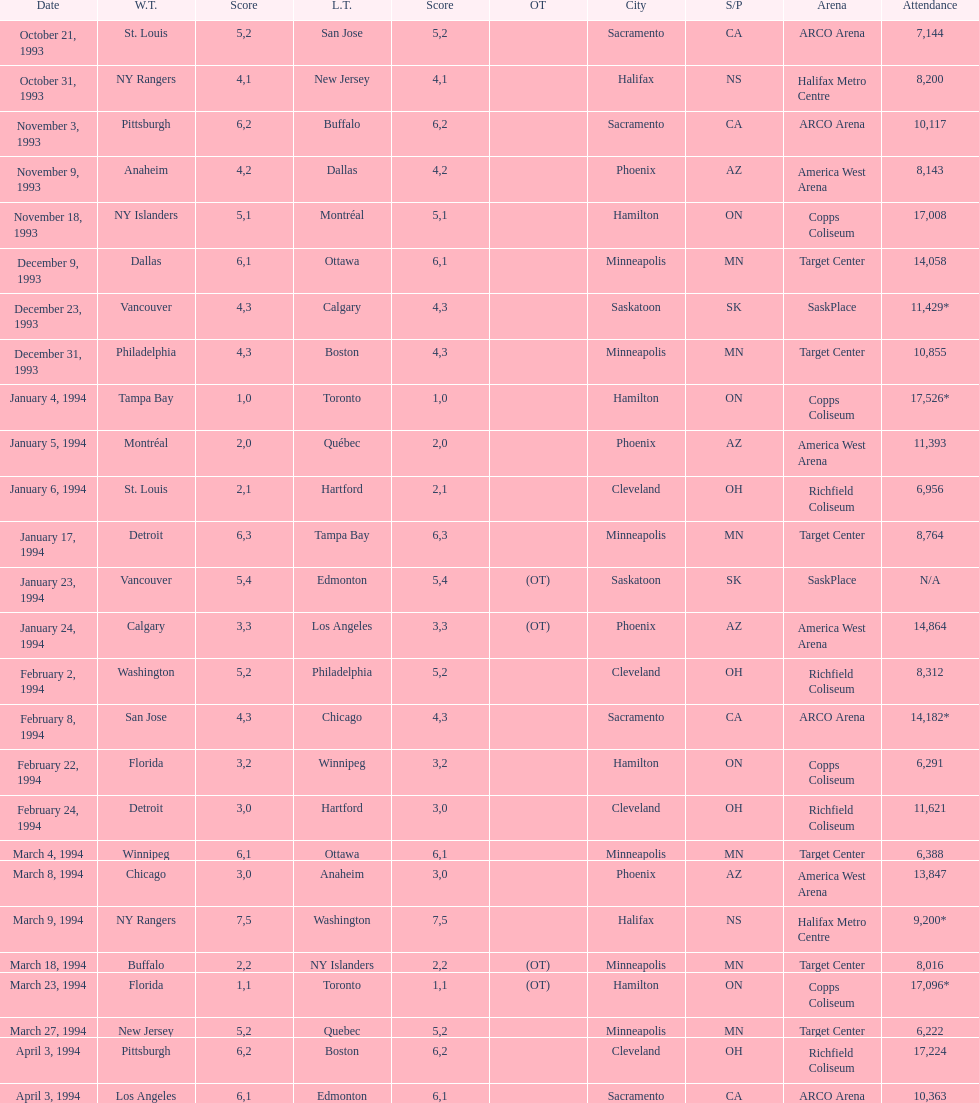I'm looking to parse the entire table for insights. Could you assist me with that? {'header': ['Date', 'W.T.', 'Score', 'L.T.', 'Score', 'OT', 'City', 'S/P', 'Arena', 'Attendance'], 'rows': [['October 21, 1993', 'St. Louis', '5', 'San Jose', '2', '', 'Sacramento', 'CA', 'ARCO Arena', '7,144'], ['October 31, 1993', 'NY Rangers', '4', 'New Jersey', '1', '', 'Halifax', 'NS', 'Halifax Metro Centre', '8,200'], ['November 3, 1993', 'Pittsburgh', '6', 'Buffalo', '2', '', 'Sacramento', 'CA', 'ARCO Arena', '10,117'], ['November 9, 1993', 'Anaheim', '4', 'Dallas', '2', '', 'Phoenix', 'AZ', 'America West Arena', '8,143'], ['November 18, 1993', 'NY Islanders', '5', 'Montréal', '1', '', 'Hamilton', 'ON', 'Copps Coliseum', '17,008'], ['December 9, 1993', 'Dallas', '6', 'Ottawa', '1', '', 'Minneapolis', 'MN', 'Target Center', '14,058'], ['December 23, 1993', 'Vancouver', '4', 'Calgary', '3', '', 'Saskatoon', 'SK', 'SaskPlace', '11,429*'], ['December 31, 1993', 'Philadelphia', '4', 'Boston', '3', '', 'Minneapolis', 'MN', 'Target Center', '10,855'], ['January 4, 1994', 'Tampa Bay', '1', 'Toronto', '0', '', 'Hamilton', 'ON', 'Copps Coliseum', '17,526*'], ['January 5, 1994', 'Montréal', '2', 'Québec', '0', '', 'Phoenix', 'AZ', 'America West Arena', '11,393'], ['January 6, 1994', 'St. Louis', '2', 'Hartford', '1', '', 'Cleveland', 'OH', 'Richfield Coliseum', '6,956'], ['January 17, 1994', 'Detroit', '6', 'Tampa Bay', '3', '', 'Minneapolis', 'MN', 'Target Center', '8,764'], ['January 23, 1994', 'Vancouver', '5', 'Edmonton', '4', '(OT)', 'Saskatoon', 'SK', 'SaskPlace', 'N/A'], ['January 24, 1994', 'Calgary', '3', 'Los Angeles', '3', '(OT)', 'Phoenix', 'AZ', 'America West Arena', '14,864'], ['February 2, 1994', 'Washington', '5', 'Philadelphia', '2', '', 'Cleveland', 'OH', 'Richfield Coliseum', '8,312'], ['February 8, 1994', 'San Jose', '4', 'Chicago', '3', '', 'Sacramento', 'CA', 'ARCO Arena', '14,182*'], ['February 22, 1994', 'Florida', '3', 'Winnipeg', '2', '', 'Hamilton', 'ON', 'Copps Coliseum', '6,291'], ['February 24, 1994', 'Detroit', '3', 'Hartford', '0', '', 'Cleveland', 'OH', 'Richfield Coliseum', '11,621'], ['March 4, 1994', 'Winnipeg', '6', 'Ottawa', '1', '', 'Minneapolis', 'MN', 'Target Center', '6,388'], ['March 8, 1994', 'Chicago', '3', 'Anaheim', '0', '', 'Phoenix', 'AZ', 'America West Arena', '13,847'], ['March 9, 1994', 'NY Rangers', '7', 'Washington', '5', '', 'Halifax', 'NS', 'Halifax Metro Centre', '9,200*'], ['March 18, 1994', 'Buffalo', '2', 'NY Islanders', '2', '(OT)', 'Minneapolis', 'MN', 'Target Center', '8,016'], ['March 23, 1994', 'Florida', '1', 'Toronto', '1', '(OT)', 'Hamilton', 'ON', 'Copps Coliseum', '17,096*'], ['March 27, 1994', 'New Jersey', '5', 'Quebec', '2', '', 'Minneapolis', 'MN', 'Target Center', '6,222'], ['April 3, 1994', 'Pittsburgh', '6', 'Boston', '2', '', 'Cleveland', 'OH', 'Richfield Coliseum', '17,224'], ['April 3, 1994', 'Los Angeles', '6', 'Edmonton', '1', '', 'Sacramento', 'CA', 'ARCO Arena', '10,363']]} How many events occurred in minneapolis, mn? 6. 